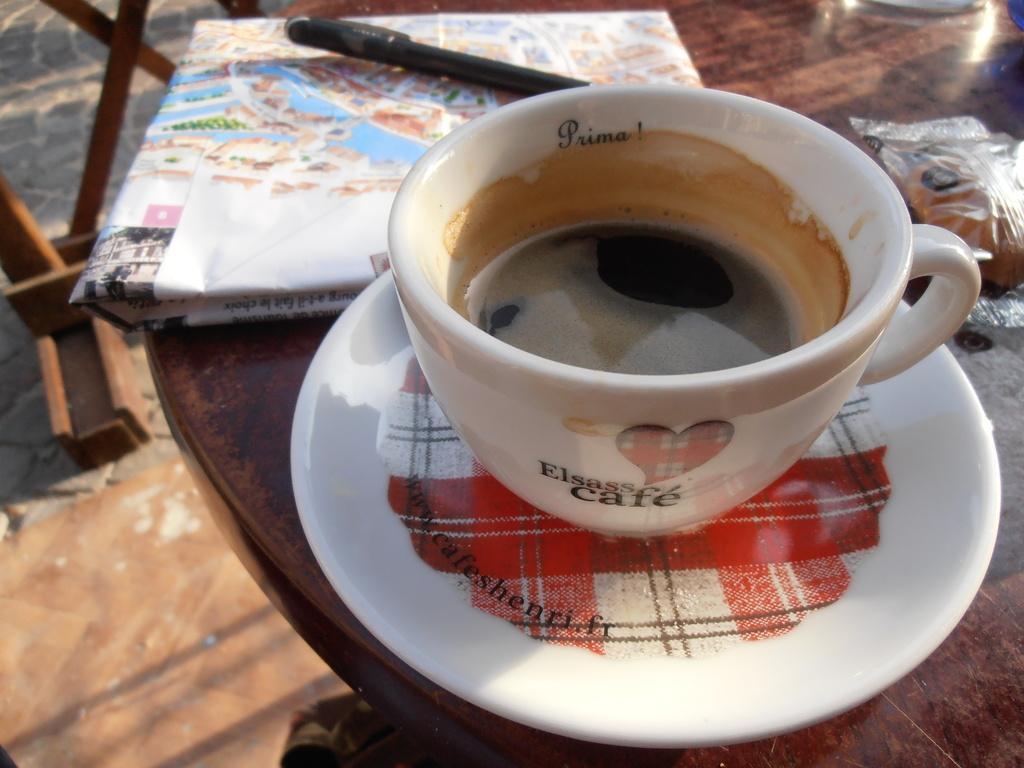Please provide a concise description of this image. In the foreground of the picture there is a table, on the table there is a saucer and a cup with coffee and a paper, a pen and a bun. To the top left there is a chair or some table. Pavement is covered with mat. 